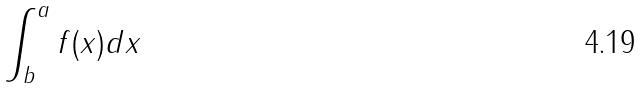Convert formula to latex. <formula><loc_0><loc_0><loc_500><loc_500>\int _ { b } ^ { a } f ( x ) d x</formula> 